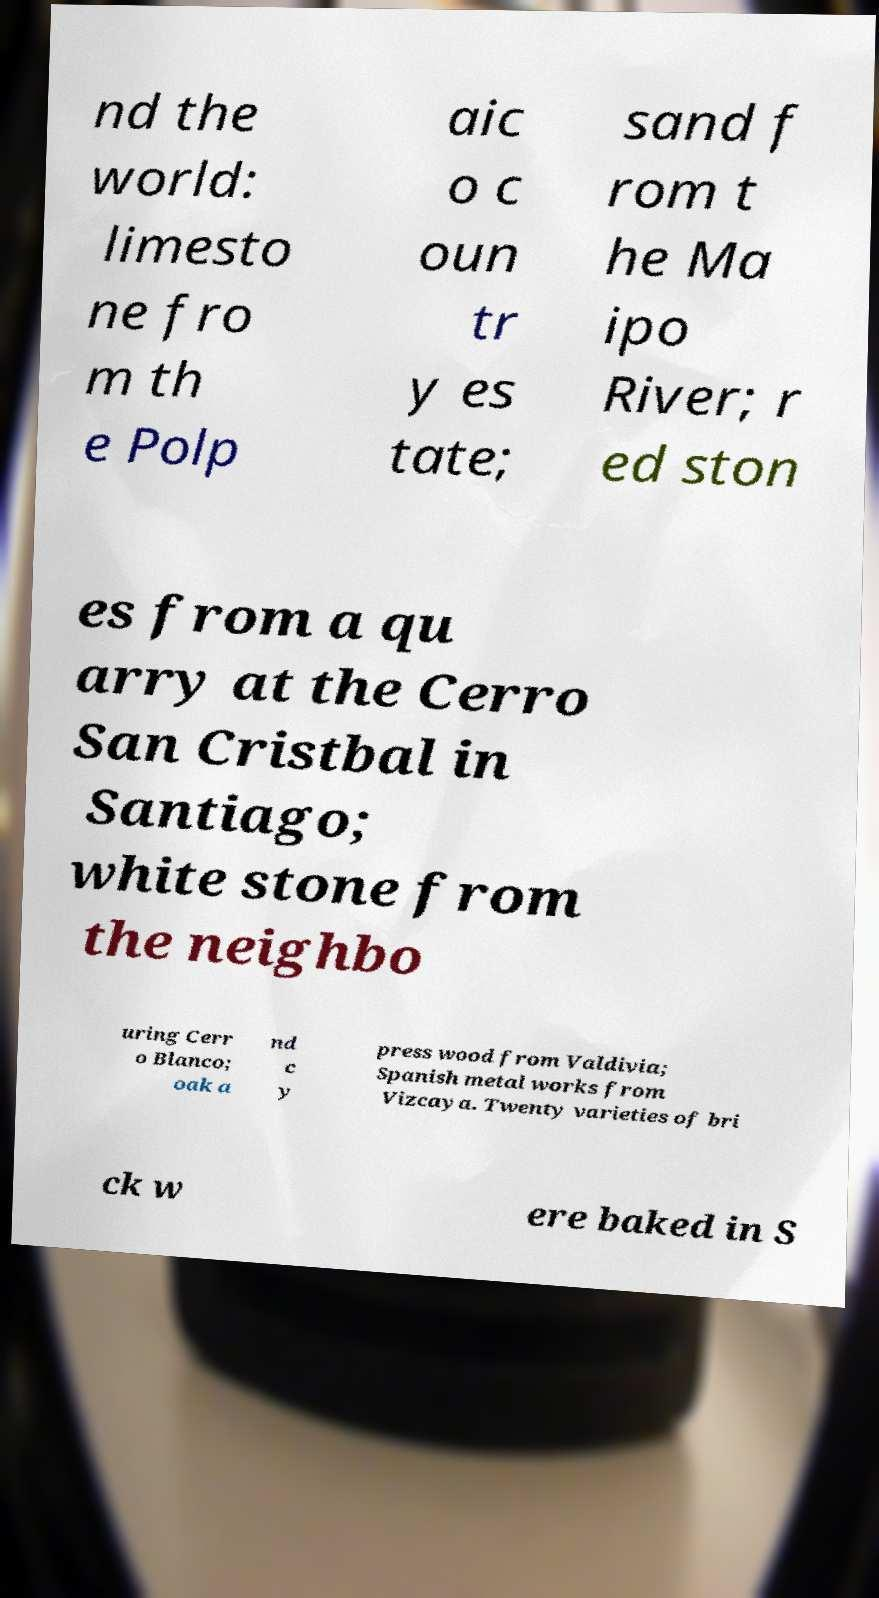Could you extract and type out the text from this image? nd the world: limesto ne fro m th e Polp aic o c oun tr y es tate; sand f rom t he Ma ipo River; r ed ston es from a qu arry at the Cerro San Cristbal in Santiago; white stone from the neighbo uring Cerr o Blanco; oak a nd c y press wood from Valdivia; Spanish metal works from Vizcaya. Twenty varieties of bri ck w ere baked in S 